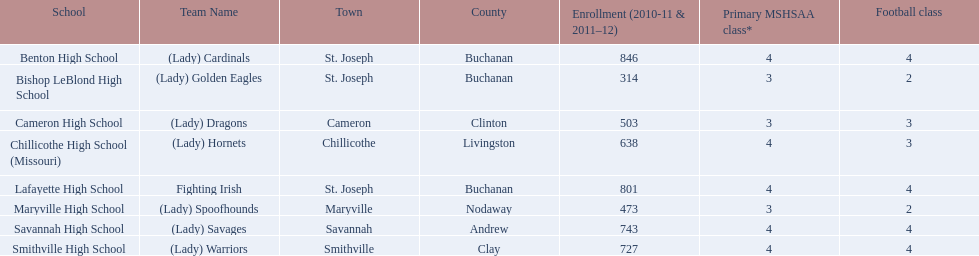What are all the educational institutions? Benton High School, Bishop LeBlond High School, Cameron High School, Chillicothe High School (Missouri), Lafayette High School, Maryville High School, Savannah High School, Smithville High School. How many football courses do they offer? 4, 2, 3, 3, 4, 2, 4, 4. What about their registration? 846, 314, 503, 638, 801, 473, 743, 727. Which institutions have 3 football courses? Cameron High School, Chillicothe High School (Missouri). And of those institutions, which has 638 learners? Chillicothe High School (Missouri). 